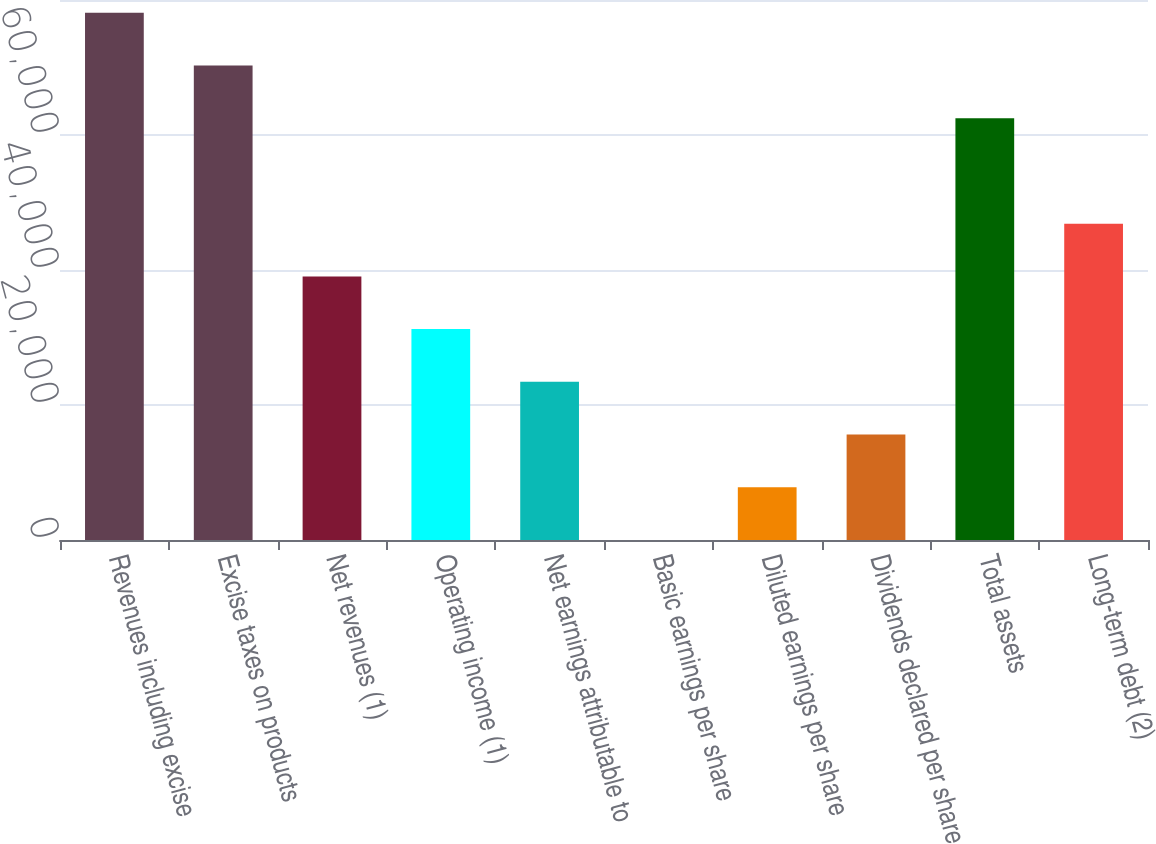Convert chart. <chart><loc_0><loc_0><loc_500><loc_500><bar_chart><fcel>Revenues including excise<fcel>Excise taxes on products<fcel>Net revenues (1)<fcel>Operating income (1)<fcel>Net earnings attributable to<fcel>Basic earnings per share<fcel>Diluted earnings per share<fcel>Dividends declared per share<fcel>Total assets<fcel>Long-term debt (2)<nl><fcel>78098<fcel>70288.6<fcel>39050.9<fcel>31241.5<fcel>23432.1<fcel>3.88<fcel>7813.29<fcel>15622.7<fcel>62479.2<fcel>46860.3<nl></chart> 